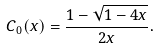Convert formula to latex. <formula><loc_0><loc_0><loc_500><loc_500>C _ { 0 } ( x ) = \frac { 1 - \sqrt { 1 - 4 x } } { 2 x } .</formula> 